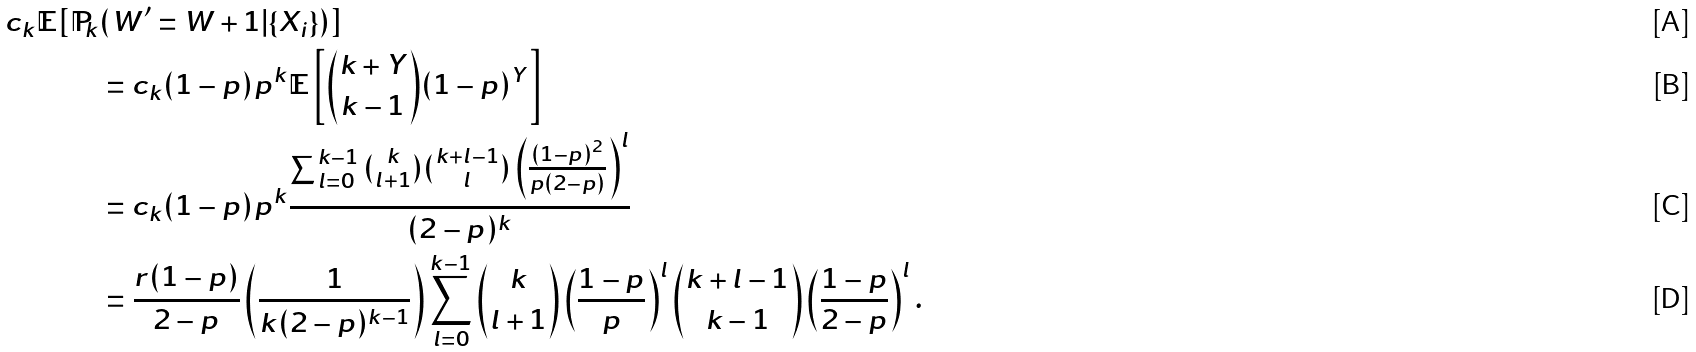<formula> <loc_0><loc_0><loc_500><loc_500>c _ { k } \mathbb { E } [ \mathbb { P } _ { k } & ( W ^ { \prime } = W + 1 | \{ X _ { i } \} ) ] \\ & = c _ { k } ( 1 - p ) p ^ { k } \mathbb { E } \left [ \binom { k + Y } { k - 1 } ( 1 - p ) ^ { Y } \right ] \\ & = c _ { k } ( 1 - p ) p ^ { k } \frac { \sum _ { l = 0 } ^ { k - 1 } \binom { k } { l + 1 } \binom { k + l - 1 } { l } \left ( \frac { ( 1 - p ) ^ { 2 } } { p ( 2 - p ) } \right ) ^ { l } } { ( 2 - p ) ^ { k } } \\ & = \frac { r ( 1 - p ) } { 2 - p } \left ( \frac { 1 } { k ( 2 - p ) ^ { k - 1 } } \right ) \sum _ { l = 0 } ^ { k - 1 } \binom { k } { l + 1 } \left ( \frac { 1 - p } { p } \right ) ^ { l } \binom { k + l - 1 } { k - 1 } \left ( \frac { 1 - p } { 2 - p } \right ) ^ { l } .</formula> 